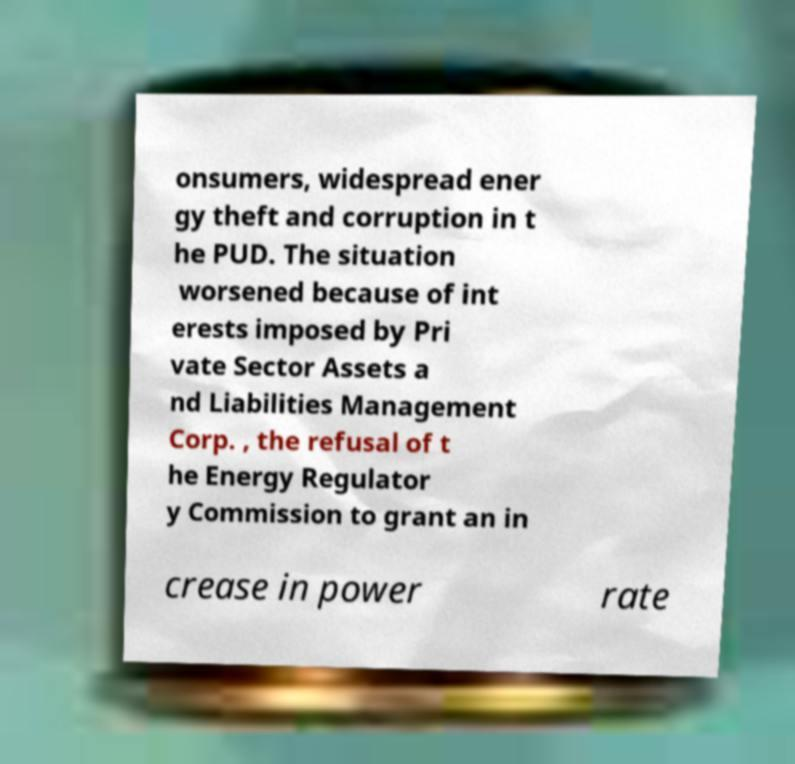For documentation purposes, I need the text within this image transcribed. Could you provide that? onsumers, widespread ener gy theft and corruption in t he PUD. The situation worsened because of int erests imposed by Pri vate Sector Assets a nd Liabilities Management Corp. , the refusal of t he Energy Regulator y Commission to grant an in crease in power rate 